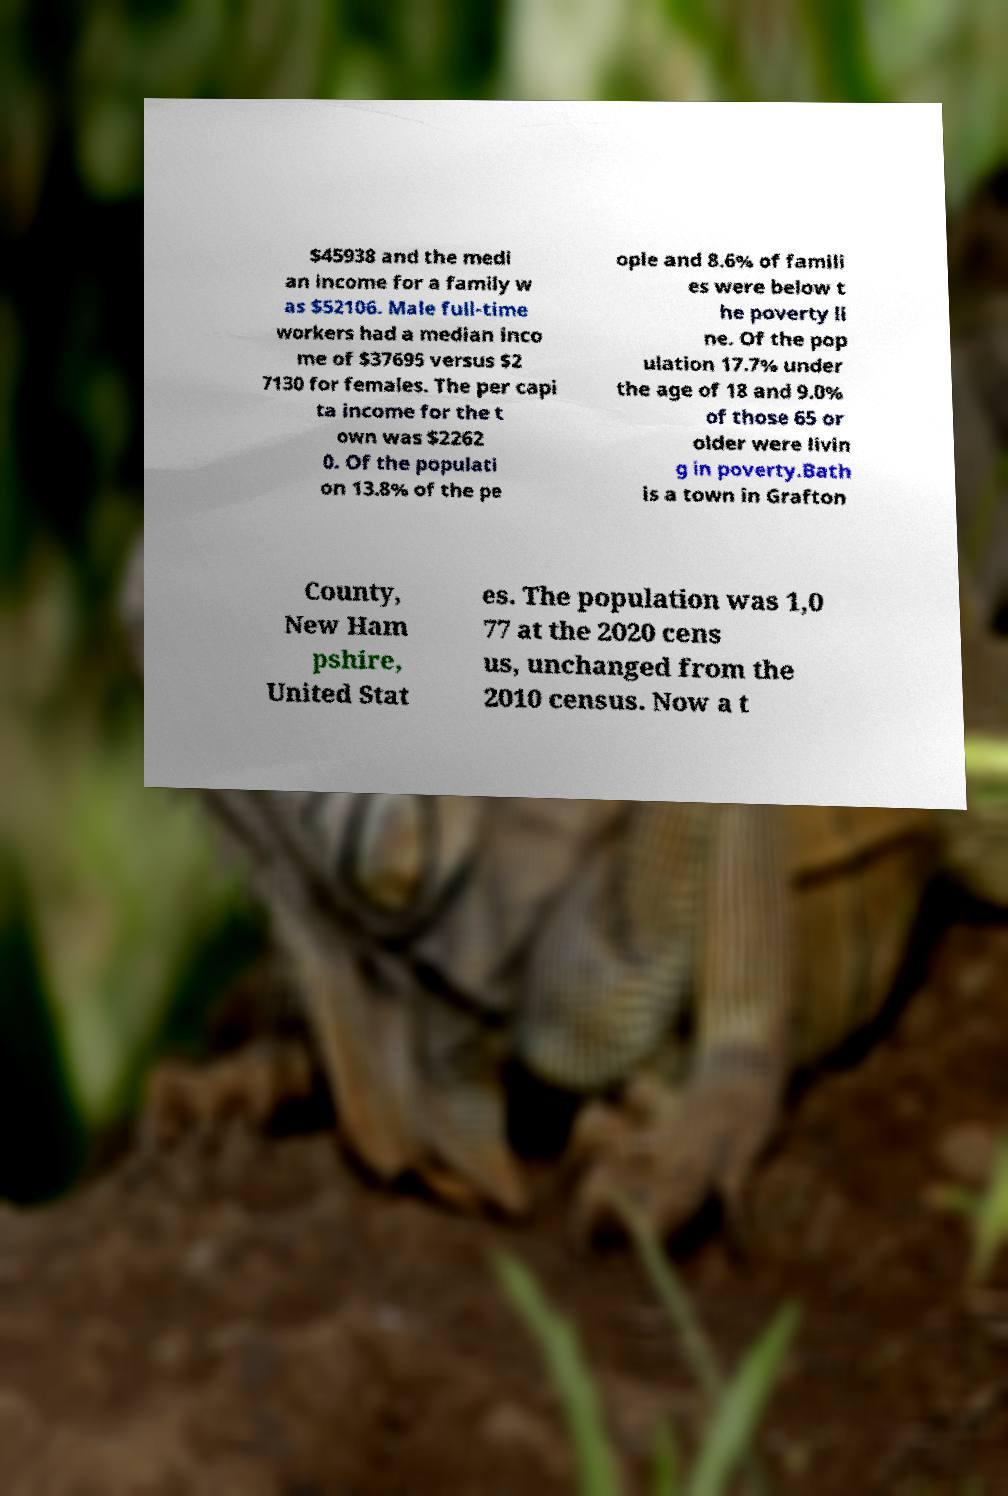Could you assist in decoding the text presented in this image and type it out clearly? $45938 and the medi an income for a family w as $52106. Male full-time workers had a median inco me of $37695 versus $2 7130 for females. The per capi ta income for the t own was $2262 0. Of the populati on 13.8% of the pe ople and 8.6% of famili es were below t he poverty li ne. Of the pop ulation 17.7% under the age of 18 and 9.0% of those 65 or older were livin g in poverty.Bath is a town in Grafton County, New Ham pshire, United Stat es. The population was 1,0 77 at the 2020 cens us, unchanged from the 2010 census. Now a t 